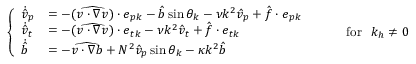Convert formula to latex. <formula><loc_0><loc_0><loc_500><loc_500>\begin{array} { r } { \left \{ \begin{array} { l l } { \dot { \hat { v } } _ { p } } & { = - ( \widehat { v \cdot \nabla v } ) \cdot e _ { p k } - \hat { b } \sin \theta _ { k } - \nu k ^ { 2 } \hat { v } _ { p } + \hat { f } \cdot e _ { p k } } \\ { \dot { \hat { v } } _ { t } } & { = - ( \widehat { v \cdot \nabla v } ) \cdot e _ { t k } - \nu k ^ { 2 } \hat { v } _ { t } + \hat { f } \cdot e _ { t k } } \\ { \dot { \hat { b } } } & { = - \widehat { v \cdot \nabla b } + N ^ { 2 } \hat { v } _ { p } \sin \theta _ { k } - \kappa k ^ { 2 } \hat { b } } \end{array} f o r k _ { h } \neq 0 } \end{array}</formula> 